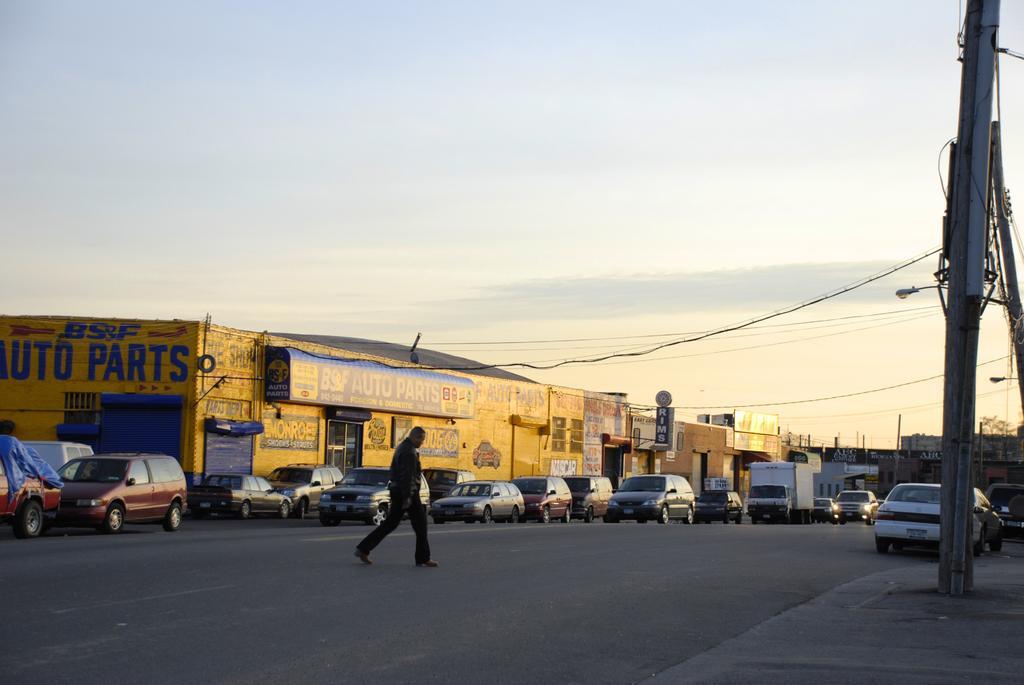How would you summarize this image in a sentence or two? In this image we can see many stores and advertising boards attached to it. There are many vehicles in the image. A person is crossing a road in the image. There are few street lights in the image. There is a sky in the image. There are few electrical poles and many cables are connected to it in the image. 